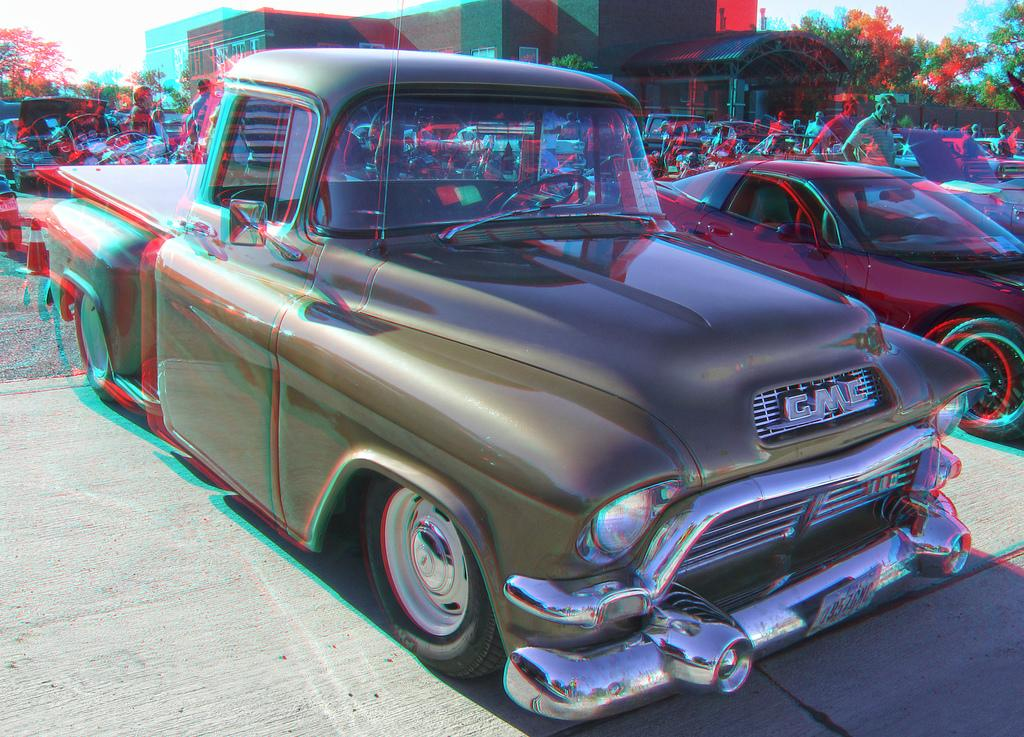What can be seen on the road in the image? There are cars parked on the road in the image. What is visible in the background of the image? There is a building and trees in the background of the image. Are there any people present in the image? Yes, there are people visible on the road in the image. What type of story is being told by the banana in the image? There is no banana present in the image, so no story can be told by a banana. 